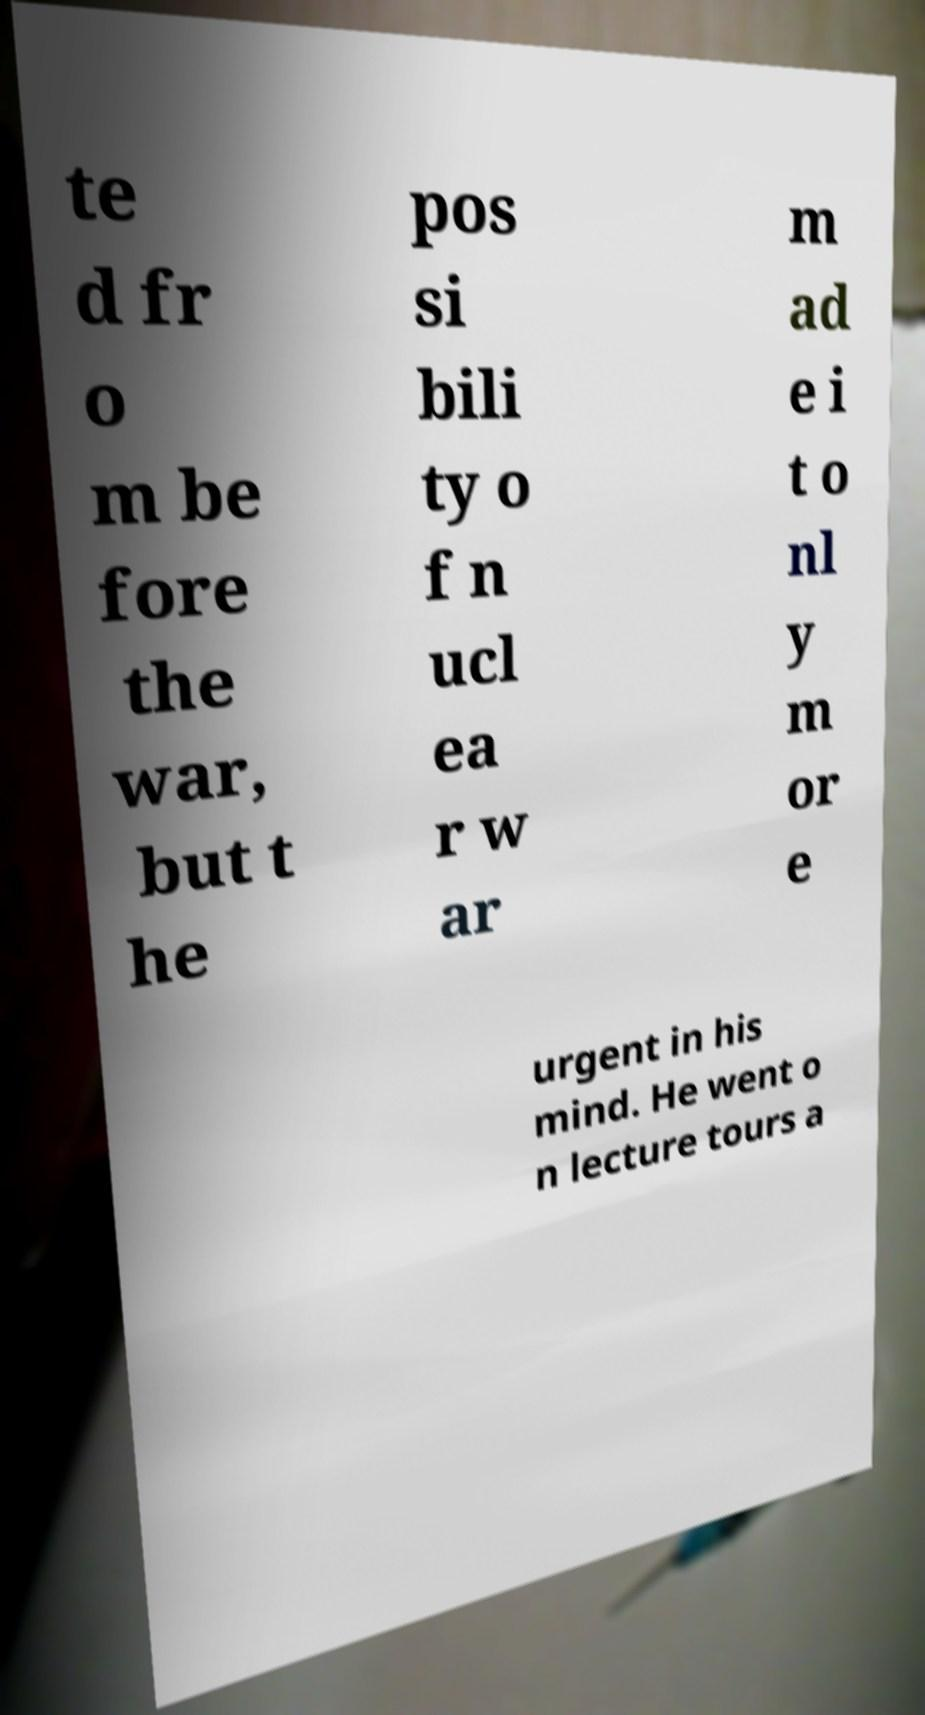I need the written content from this picture converted into text. Can you do that? te d fr o m be fore the war, but t he pos si bili ty o f n ucl ea r w ar m ad e i t o nl y m or e urgent in his mind. He went o n lecture tours a 